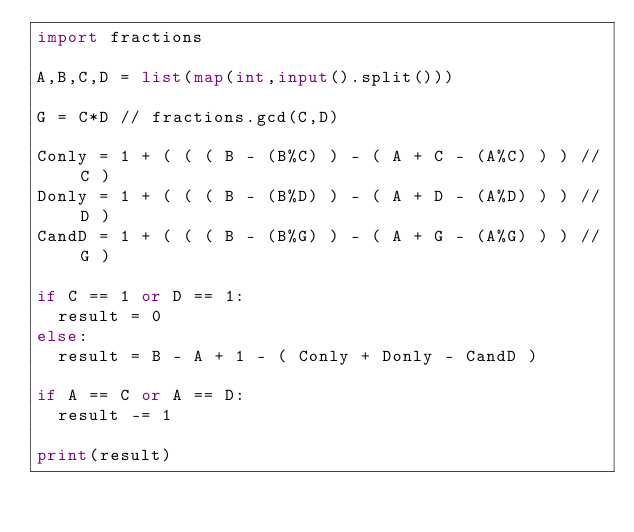Convert code to text. <code><loc_0><loc_0><loc_500><loc_500><_Python_>import fractions

A,B,C,D = list(map(int,input().split()))

G = C*D // fractions.gcd(C,D)

Conly = 1 + ( ( ( B - (B%C) ) - ( A + C - (A%C) ) ) // C )
Donly = 1 + ( ( ( B - (B%D) ) - ( A + D - (A%D) ) ) // D )
CandD = 1 + ( ( ( B - (B%G) ) - ( A + G - (A%G) ) ) // G )

if C == 1 or D == 1:
  result = 0
else:
  result = B - A + 1 - ( Conly + Donly - CandD )
  
if A == C or A == D:
  result -= 1

print(result)

</code> 